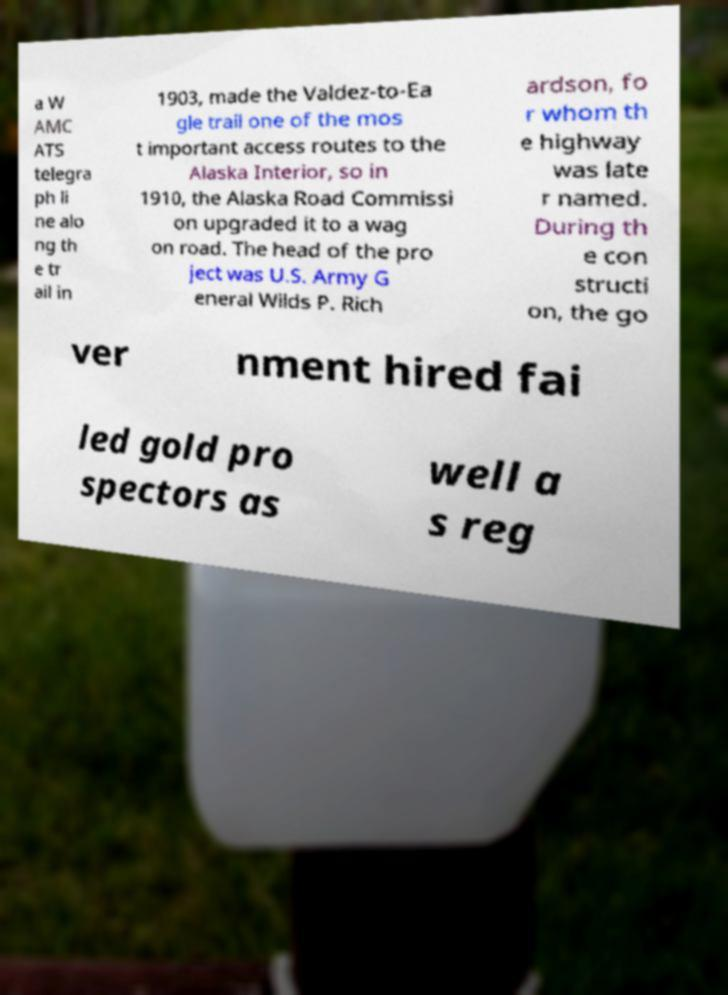Can you accurately transcribe the text from the provided image for me? a W AMC ATS telegra ph li ne alo ng th e tr ail in 1903, made the Valdez-to-Ea gle trail one of the mos t important access routes to the Alaska Interior, so in 1910, the Alaska Road Commissi on upgraded it to a wag on road. The head of the pro ject was U.S. Army G eneral Wilds P. Rich ardson, fo r whom th e highway was late r named. During th e con structi on, the go ver nment hired fai led gold pro spectors as well a s reg 